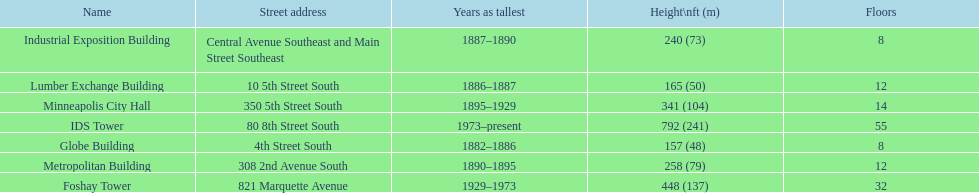After ids tower what is the second tallest building in minneapolis? Foshay Tower. 